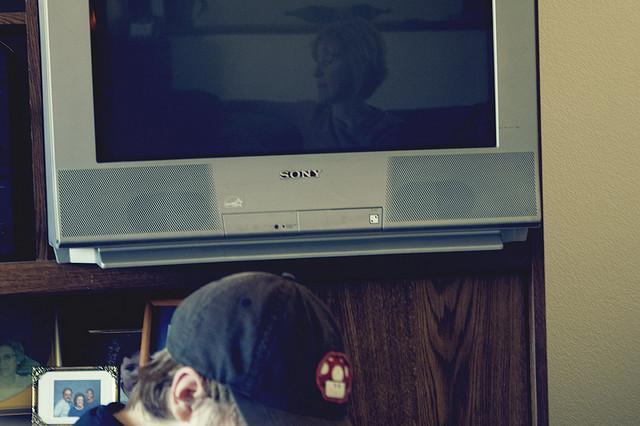When did the TV company start using this name?
Choose the right answer and clarify with the format: 'Answer: answer
Rationale: rationale.'
Options: 1958, 1962, 1935, 1945. Answer: 1958.
Rationale: This was 12 years after the company was founded 